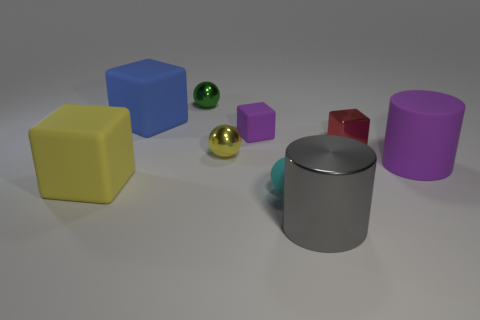Does the cyan object have the same size as the yellow metallic thing? The cyan object, which appears to be a cylinder, seems somewhat larger in height compared to the yellow cube, but without knowing their exact dimensions, it's difficult to confirm if they are truly the same size in terms of volume or area. It may also depend on which dimension—height, width, or depth—you are considering for 'size'. 